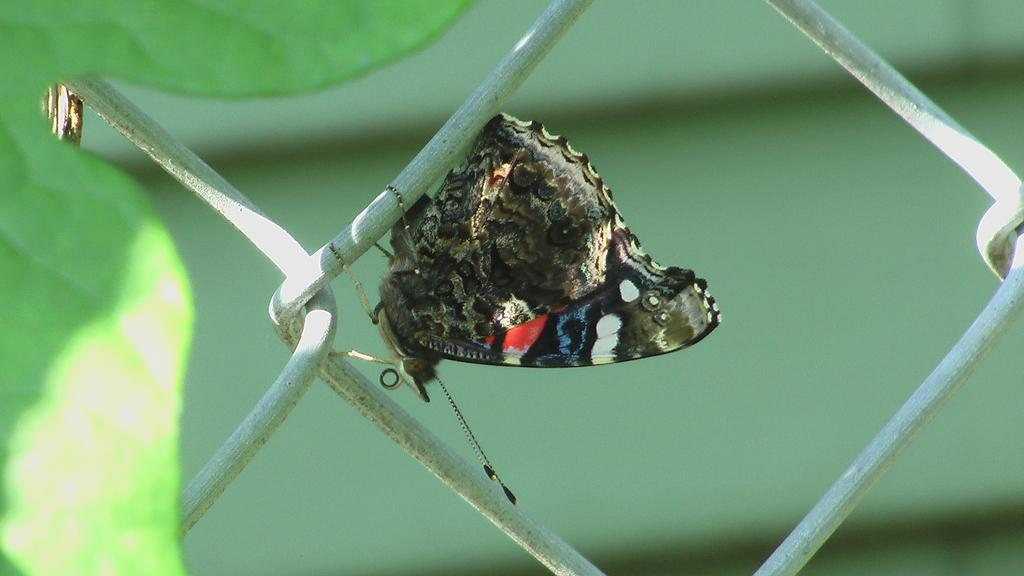What is the main subject of the image? There is a butterfly in the image. Where is the butterfly located? The butterfly is on a fence. What else can be seen on the left side of the image? There is a leaf on the left side of the image. What angle does the butterfly make with the fence in the image? The angle between the butterfly and the fence cannot be determined from the image, as it only shows the butterfly on the fence without providing any information about the angle. 